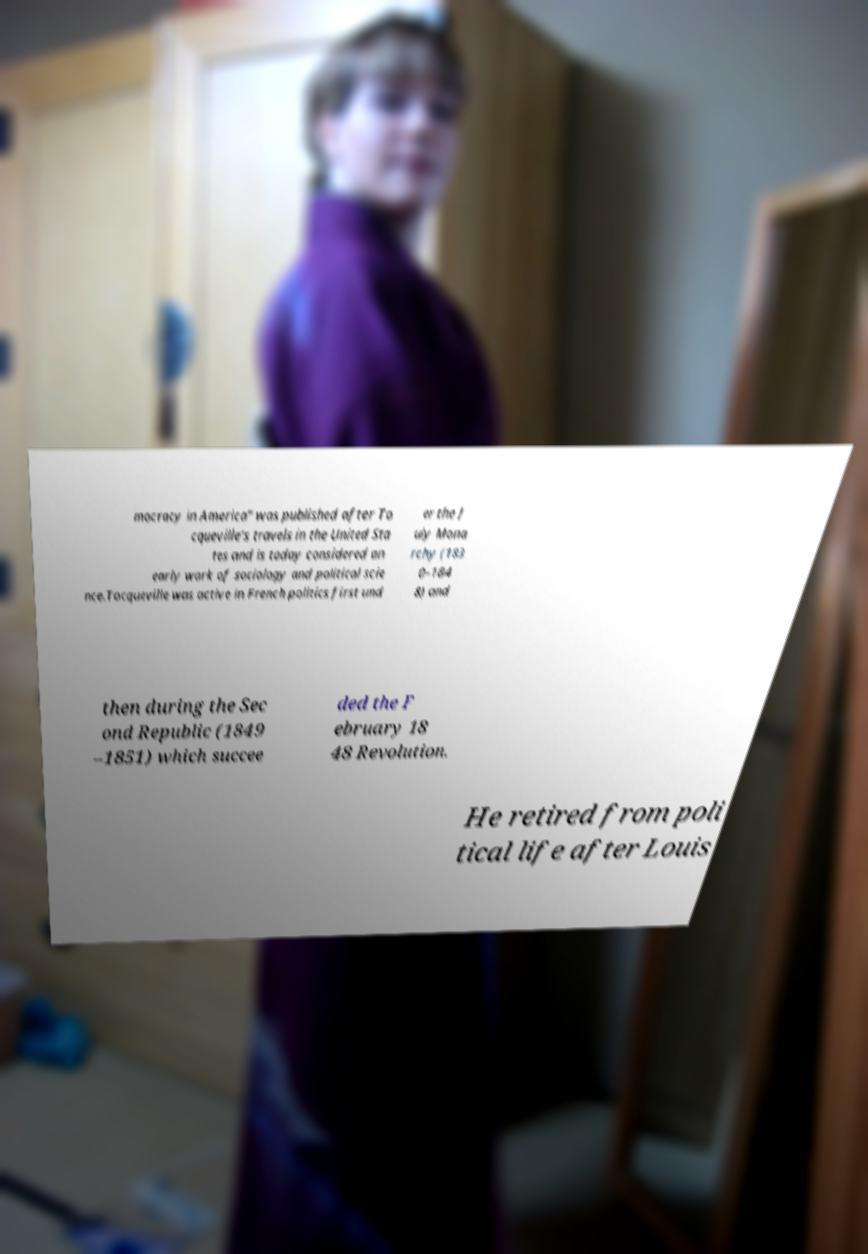What messages or text are displayed in this image? I need them in a readable, typed format. mocracy in America" was published after To cqueville's travels in the United Sta tes and is today considered an early work of sociology and political scie nce.Tocqueville was active in French politics first und er the J uly Mona rchy (183 0–184 8) and then during the Sec ond Republic (1849 –1851) which succee ded the F ebruary 18 48 Revolution. He retired from poli tical life after Louis 